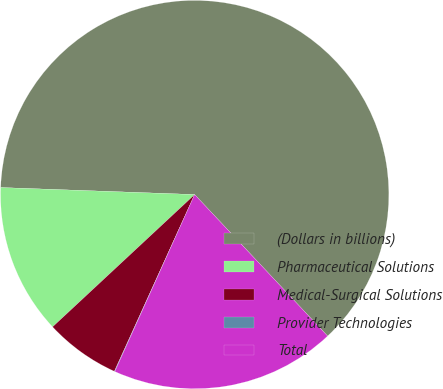Convert chart to OTSL. <chart><loc_0><loc_0><loc_500><loc_500><pie_chart><fcel>(Dollars in billions)<fcel>Pharmaceutical Solutions<fcel>Medical-Surgical Solutions<fcel>Provider Technologies<fcel>Total<nl><fcel>62.42%<fcel>12.51%<fcel>6.28%<fcel>0.04%<fcel>18.75%<nl></chart> 